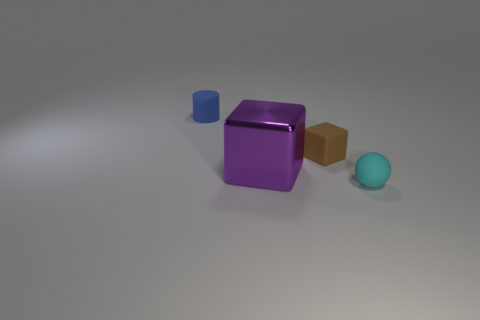Is there any other thing that is made of the same material as the big purple object?
Give a very brief answer. No. There is another tiny object that is the same shape as the purple metal object; what is it made of?
Offer a terse response. Rubber. What color is the small matte block?
Keep it short and to the point. Brown. Is the rubber cube the same color as the large shiny thing?
Provide a succinct answer. No. How many rubber objects are either tiny spheres or large blocks?
Make the answer very short. 1. There is a small object in front of the cube to the right of the purple thing; are there any blue rubber cylinders in front of it?
Ensure brevity in your answer.  No. There is a brown thing that is the same material as the blue cylinder; what is its size?
Offer a very short reply. Small. Are there any tiny rubber spheres behind the brown matte cube?
Your response must be concise. No. There is a tiny thing that is right of the brown rubber block; is there a rubber sphere on the left side of it?
Offer a terse response. No. Is the size of the block that is on the right side of the big block the same as the matte thing that is behind the small block?
Your answer should be very brief. Yes. 